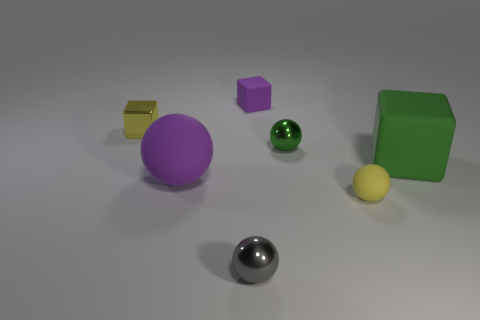Subtract all big purple spheres. How many spheres are left? 3 Subtract all purple cubes. How many cubes are left? 2 Subtract all balls. How many objects are left? 3 Subtract 1 blocks. How many blocks are left? 2 Add 2 red spheres. How many objects exist? 9 Subtract 0 green cylinders. How many objects are left? 7 Subtract all cyan blocks. Subtract all purple balls. How many blocks are left? 3 Subtract all gray cylinders. How many green balls are left? 1 Subtract all tiny rubber cylinders. Subtract all green rubber cubes. How many objects are left? 6 Add 6 yellow metal blocks. How many yellow metal blocks are left? 7 